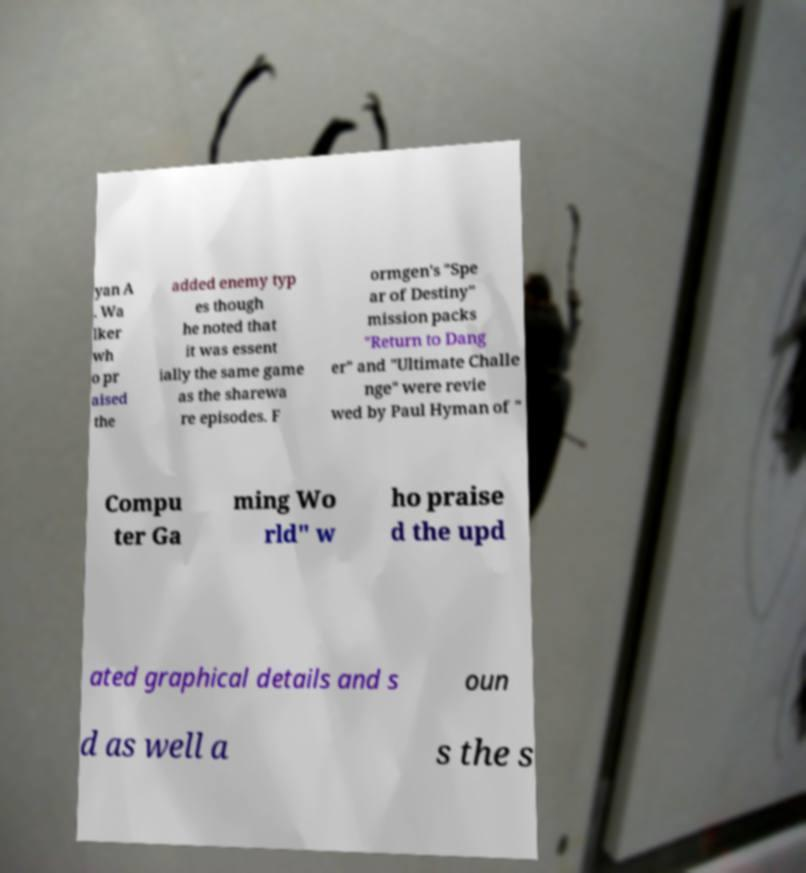For documentation purposes, I need the text within this image transcribed. Could you provide that? yan A . Wa lker wh o pr aised the added enemy typ es though he noted that it was essent ially the same game as the sharewa re episodes. F ormgen's "Spe ar of Destiny" mission packs "Return to Dang er" and "Ultimate Challe nge" were revie wed by Paul Hyman of " Compu ter Ga ming Wo rld" w ho praise d the upd ated graphical details and s oun d as well a s the s 